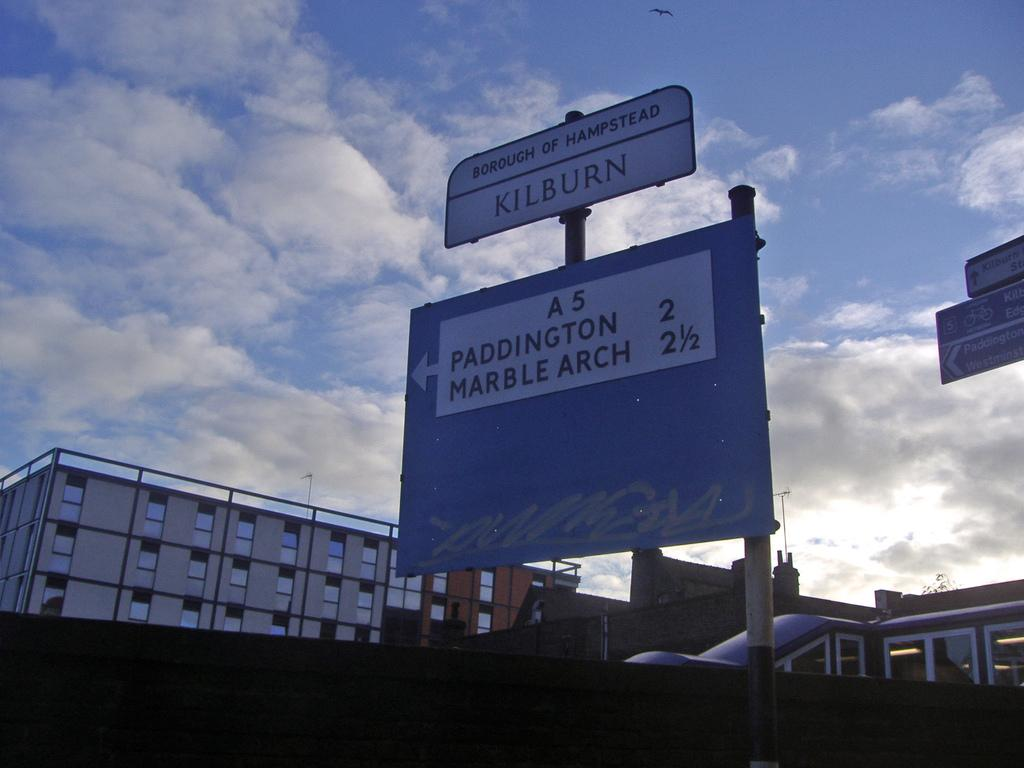Provide a one-sentence caption for the provided image. A street sign showing the distances to Paddington and Marble Arch. 